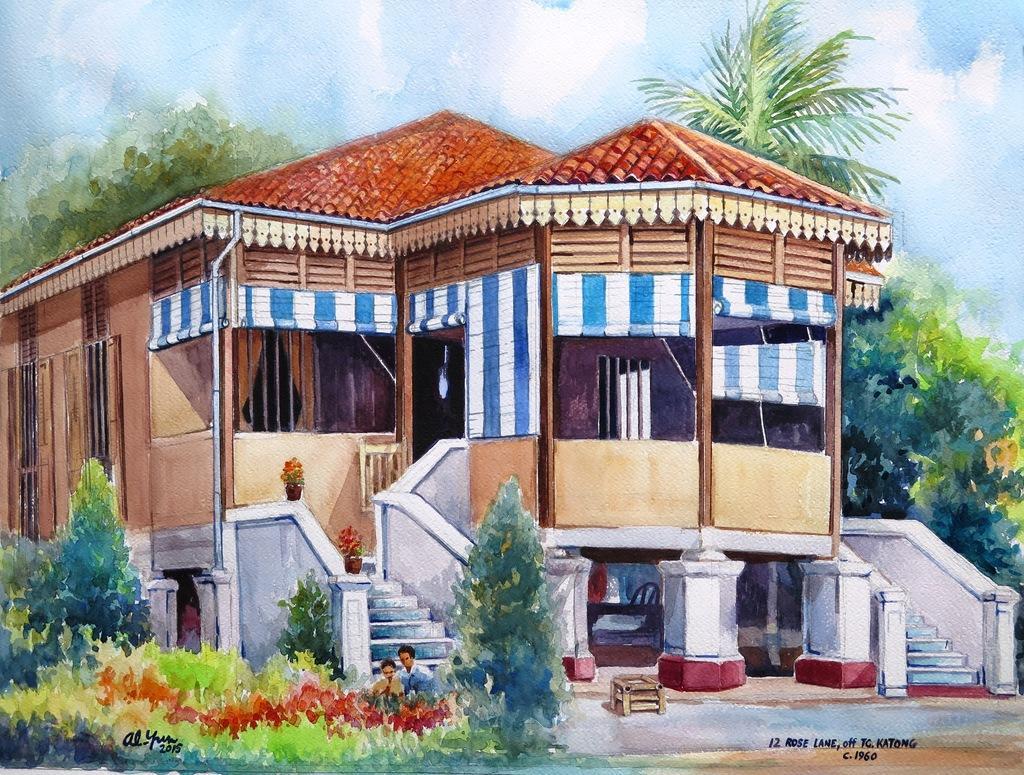Please provide a concise description of this image. In the picture there is a painting of a beautiful house and around the house there are many trees. 